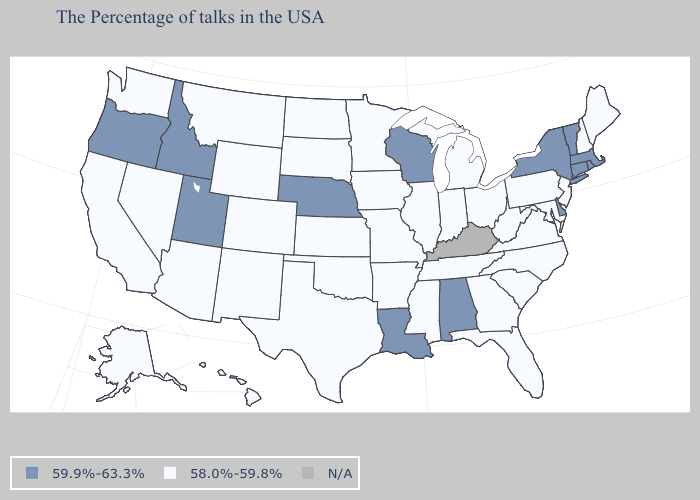What is the value of Washington?
Write a very short answer. 58.0%-59.8%. What is the value of Louisiana?
Write a very short answer. 59.9%-63.3%. What is the lowest value in the USA?
Answer briefly. 58.0%-59.8%. Among the states that border North Carolina , which have the highest value?
Keep it brief. Virginia, South Carolina, Georgia, Tennessee. What is the value of Florida?
Concise answer only. 58.0%-59.8%. Among the states that border Texas , does Louisiana have the lowest value?
Give a very brief answer. No. Name the states that have a value in the range N/A?
Be succinct. Kentucky. Does Vermont have the lowest value in the Northeast?
Write a very short answer. No. Name the states that have a value in the range N/A?
Answer briefly. Kentucky. Name the states that have a value in the range N/A?
Write a very short answer. Kentucky. What is the value of Tennessee?
Quick response, please. 58.0%-59.8%. What is the value of Colorado?
Keep it brief. 58.0%-59.8%. Name the states that have a value in the range 59.9%-63.3%?
Write a very short answer. Massachusetts, Rhode Island, Vermont, Connecticut, New York, Delaware, Alabama, Wisconsin, Louisiana, Nebraska, Utah, Idaho, Oregon. 